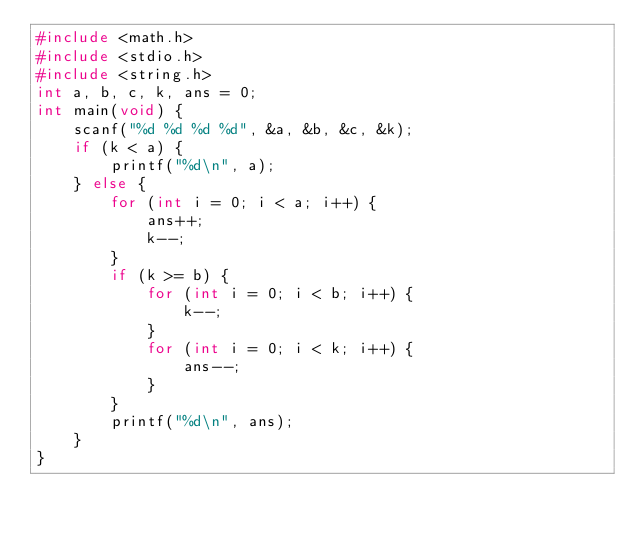Convert code to text. <code><loc_0><loc_0><loc_500><loc_500><_C_>#include <math.h>
#include <stdio.h>
#include <string.h>
int a, b, c, k, ans = 0;
int main(void) {
    scanf("%d %d %d %d", &a, &b, &c, &k);
    if (k < a) {
        printf("%d\n", a);
    } else {
        for (int i = 0; i < a; i++) {
            ans++;
            k--;
        }
        if (k >= b) {
            for (int i = 0; i < b; i++) {
                k--;
            }
            for (int i = 0; i < k; i++) {
                ans--;
            }
        }
        printf("%d\n", ans);
    }
}</code> 